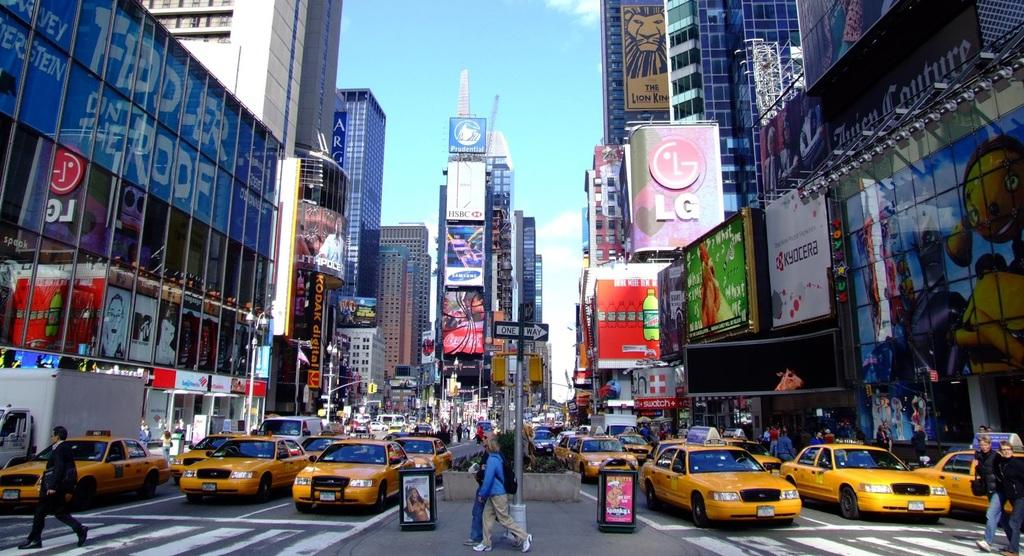<image>
Relay a brief, clear account of the picture shown. Downtown City with lots of Taxi Cabs and an LG building on left with Fiddler on the Roof. 